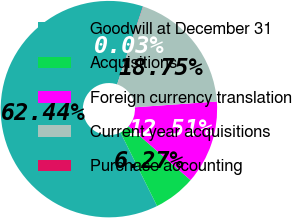Convert chart. <chart><loc_0><loc_0><loc_500><loc_500><pie_chart><fcel>Goodwill at December 31<fcel>Acquisitions<fcel>Foreign currency translation<fcel>Current year acquisitions<fcel>Purchase accounting<nl><fcel>62.43%<fcel>6.27%<fcel>12.51%<fcel>18.75%<fcel>0.03%<nl></chart> 